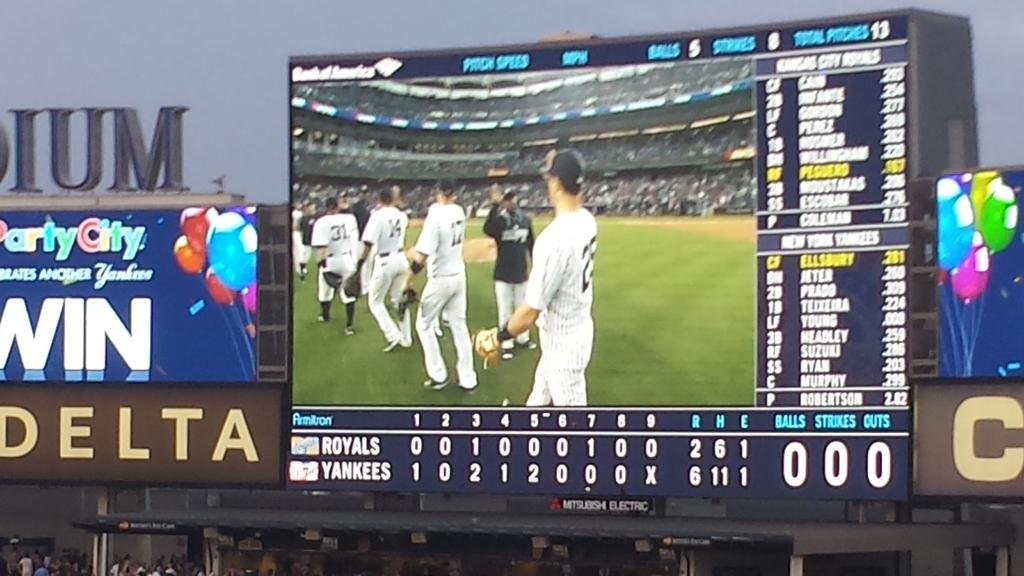<image>
Give a short and clear explanation of the subsequent image. A baseball scoreboard displays the stats for a game between the Royals and the Yankees. 